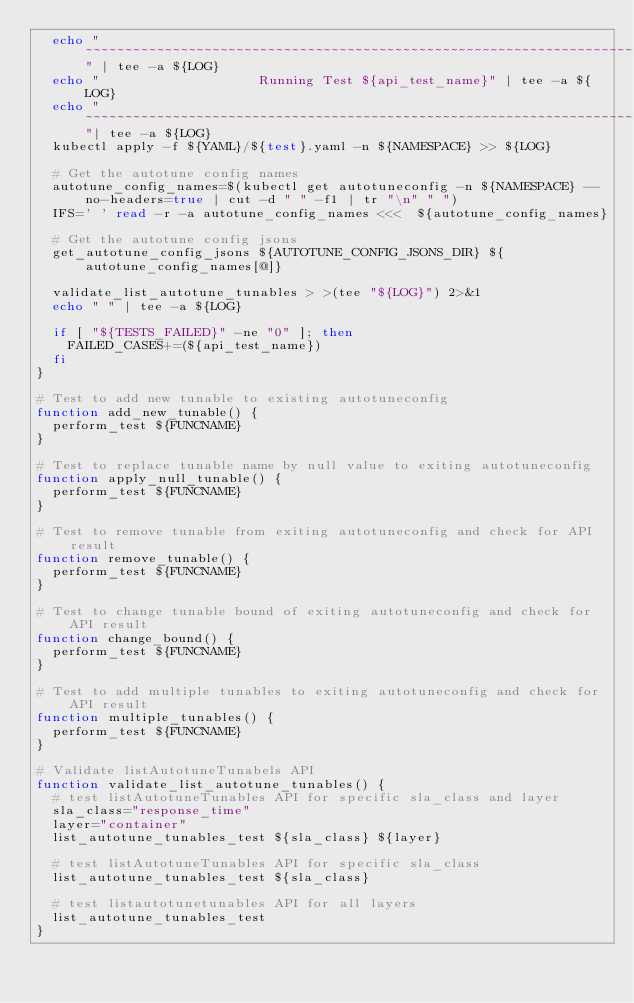<code> <loc_0><loc_0><loc_500><loc_500><_Bash_>	echo "~~~~~~~~~~~~~~~~~~~~~~~~~~~~~~~~~~~~~~~~~~~~~~~~~~~~~~~~~~~~~~~~~~~~~~~~~~~~~~~" | tee -a ${LOG}
	echo "                    Running Test ${api_test_name}" | tee -a ${LOG}
	echo "~~~~~~~~~~~~~~~~~~~~~~~~~~~~~~~~~~~~~~~~~~~~~~~~~~~~~~~~~~~~~~~~~~~~~~~~~~~~~~~"| tee -a ${LOG}
	kubectl apply -f ${YAML}/${test}.yaml -n ${NAMESPACE} >> ${LOG}
	
	# Get the autotune config names 
	autotune_config_names=$(kubectl get autotuneconfig -n ${NAMESPACE} --no-headers=true | cut -d " " -f1 | tr "\n" " ")
	IFS=' ' read -r -a autotune_config_names <<<  ${autotune_config_names}
	
	# Get the autotune config jsons
	get_autotune_config_jsons ${AUTOTUNE_CONFIG_JSONS_DIR} ${autotune_config_names[@]}
	
	validate_list_autotune_tunables > >(tee "${LOG}") 2>&1
	echo " " | tee -a ${LOG}
	
	if [ "${TESTS_FAILED}" -ne "0" ]; then
		FAILED_CASES+=(${api_test_name})
	fi
}

# Test to add new tunable to existing autotuneconfig
function add_new_tunable() {
	perform_test ${FUNCNAME} 
}

# Test to replace tunable name by null value to exiting autotuneconfig
function apply_null_tunable() {
	perform_test ${FUNCNAME}
}

# Test to remove tunable from exiting autotuneconfig and check for API result
function remove_tunable() {
	perform_test ${FUNCNAME}
}

# Test to change tunable bound of exiting autotuneconfig and check for API result
function change_bound() {
	perform_test ${FUNCNAME}
}

# Test to add multiple tunables to exiting autotuneconfig and check for API result
function multiple_tunables() {
	perform_test ${FUNCNAME}
}

# Validate listAutotuneTunabels API 
function validate_list_autotune_tunables() {
	# test listAutotuneTunables API for specific sla_class and layer
	sla_class="response_time"
	layer="container"
	list_autotune_tunables_test ${sla_class} ${layer}

	# test listAutotuneTunables API for specific sla_class
	list_autotune_tunables_test ${sla_class} 
	
	# test listautotunetunables API for all layers
	list_autotune_tunables_test
}
</code> 